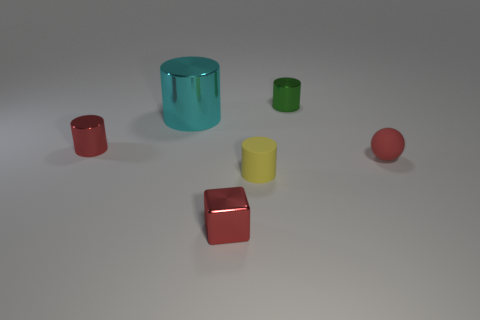Subtract all shiny cylinders. How many cylinders are left? 1 Add 2 rubber cubes. How many objects exist? 8 Subtract all cubes. How many objects are left? 5 Subtract all cyan cylinders. How many cylinders are left? 3 Add 6 yellow cylinders. How many yellow cylinders are left? 7 Add 5 tiny red cubes. How many tiny red cubes exist? 6 Subtract 0 cyan cubes. How many objects are left? 6 Subtract all brown balls. Subtract all red blocks. How many balls are left? 1 Subtract all tiny yellow rubber cylinders. Subtract all tiny rubber cylinders. How many objects are left? 4 